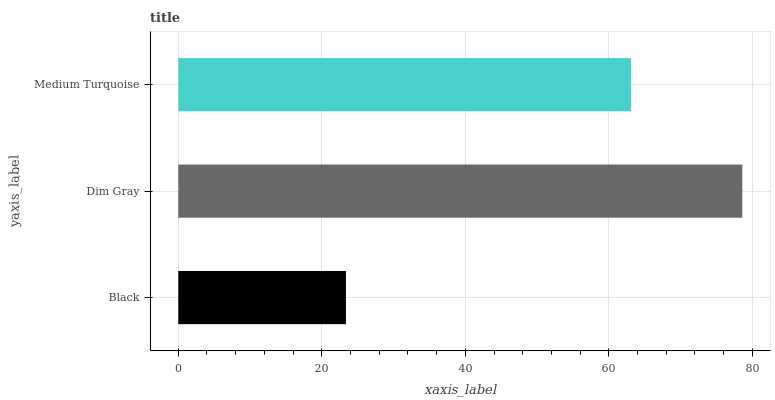Is Black the minimum?
Answer yes or no. Yes. Is Dim Gray the maximum?
Answer yes or no. Yes. Is Medium Turquoise the minimum?
Answer yes or no. No. Is Medium Turquoise the maximum?
Answer yes or no. No. Is Dim Gray greater than Medium Turquoise?
Answer yes or no. Yes. Is Medium Turquoise less than Dim Gray?
Answer yes or no. Yes. Is Medium Turquoise greater than Dim Gray?
Answer yes or no. No. Is Dim Gray less than Medium Turquoise?
Answer yes or no. No. Is Medium Turquoise the high median?
Answer yes or no. Yes. Is Medium Turquoise the low median?
Answer yes or no. Yes. Is Black the high median?
Answer yes or no. No. Is Dim Gray the low median?
Answer yes or no. No. 